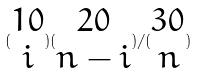Convert formula to latex. <formula><loc_0><loc_0><loc_500><loc_500>( \begin{matrix} 1 0 \\ i \end{matrix} ) ( \begin{matrix} 2 0 \\ n - i \end{matrix} ) / ( \begin{matrix} 3 0 \\ n \end{matrix} )</formula> 